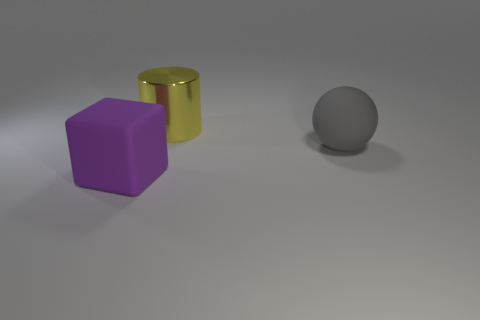There is a thing that is the same material as the big ball; what is its shape? cube 